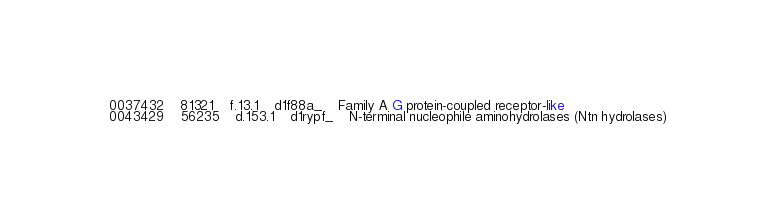Convert code to text. <code><loc_0><loc_0><loc_500><loc_500><_SQL_>0037432	81321	f.13.1	d1f88a_	Family A G protein-coupled receptor-like
0043429	56235	d.153.1	d1rypf_	N-terminal nucleophile aminohydrolases (Ntn hydrolases)
</code> 